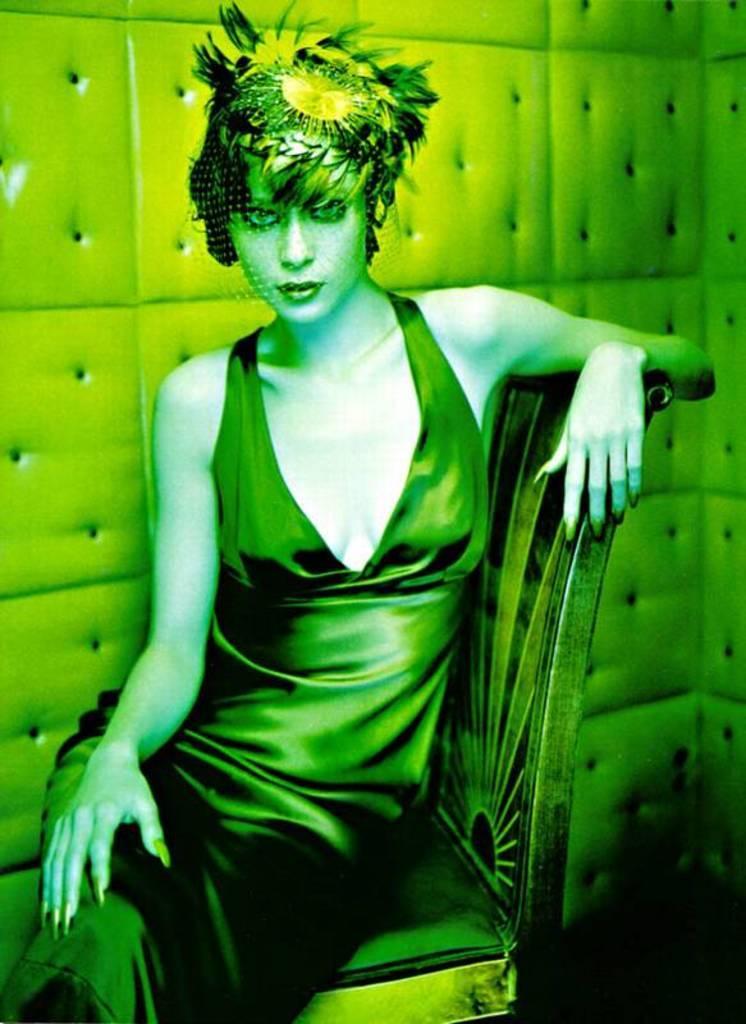Please provide a concise description of this image. I see that this image is of green in color and I see a woman over here who is sitting on a chair. 